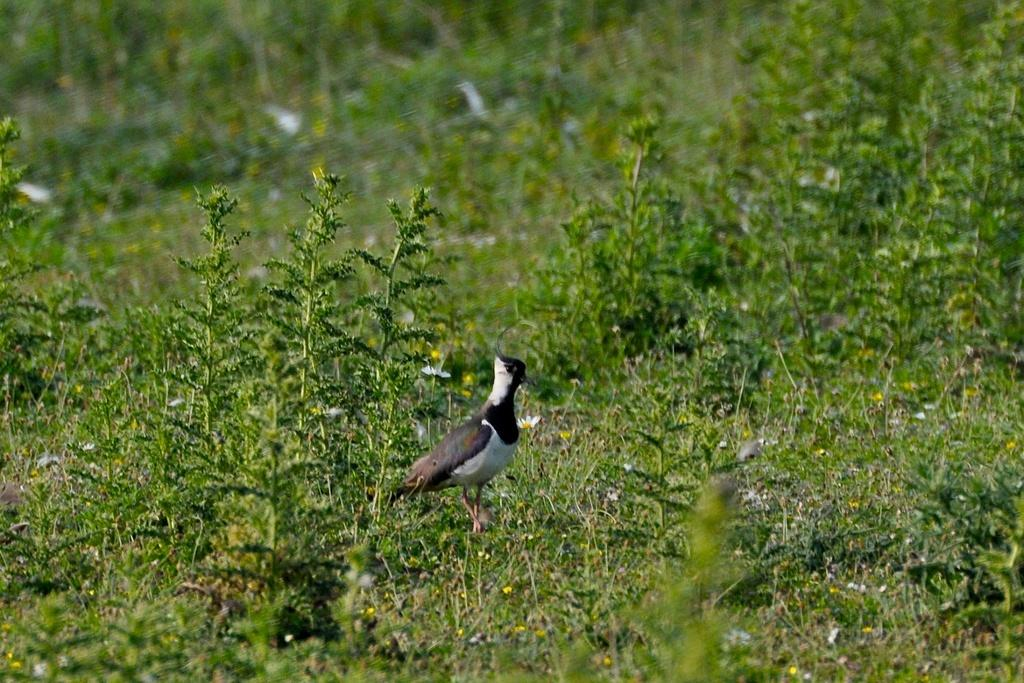What type of vegetation is present in the image? There is grass in the image. What type of animal can be seen in the image? There is a bird in the image. How is the bird depicted in terms of color? The bird is in black and white. Can you describe the quality of the top portion of the image? The top portion of the image is blurred. Is there a bear visible in the image? No, there is no bear present in the image. Does the existence of the bird in the image prove the existence of all birds in real life? The presence of the bird in the image does not prove the existence of all birds in real life; it only confirms that there is a bird in this particular image. 